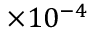<formula> <loc_0><loc_0><loc_500><loc_500>\times 1 0 ^ { - 4 }</formula> 